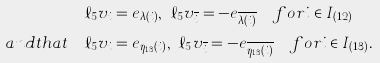Convert formula to latex. <formula><loc_0><loc_0><loc_500><loc_500>\ell _ { 5 } v _ { i } & = e _ { \lambda ( i ) } , \ \ell _ { 5 } v _ { \overline { i } } = - e _ { \overline { \lambda ( i ) } } \quad f o r i \in I _ { ( 1 2 ) } \\ a n d t h a t \quad \ell _ { 5 } v _ { i } & = e _ { \eta _ { 1 3 } ( i ) } , \ \ell _ { 5 } v _ { \overline { i } } = - e _ { \overline { \eta _ { 1 3 } ( i ) } } \quad f o r i \in I _ { ( 1 3 ) } .</formula> 